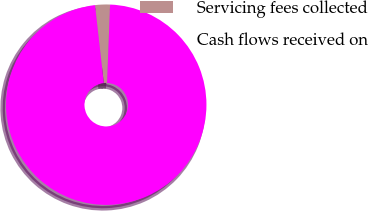Convert chart. <chart><loc_0><loc_0><loc_500><loc_500><pie_chart><fcel>Servicing fees collected<fcel>Cash flows received on<nl><fcel>2.4%<fcel>97.6%<nl></chart> 